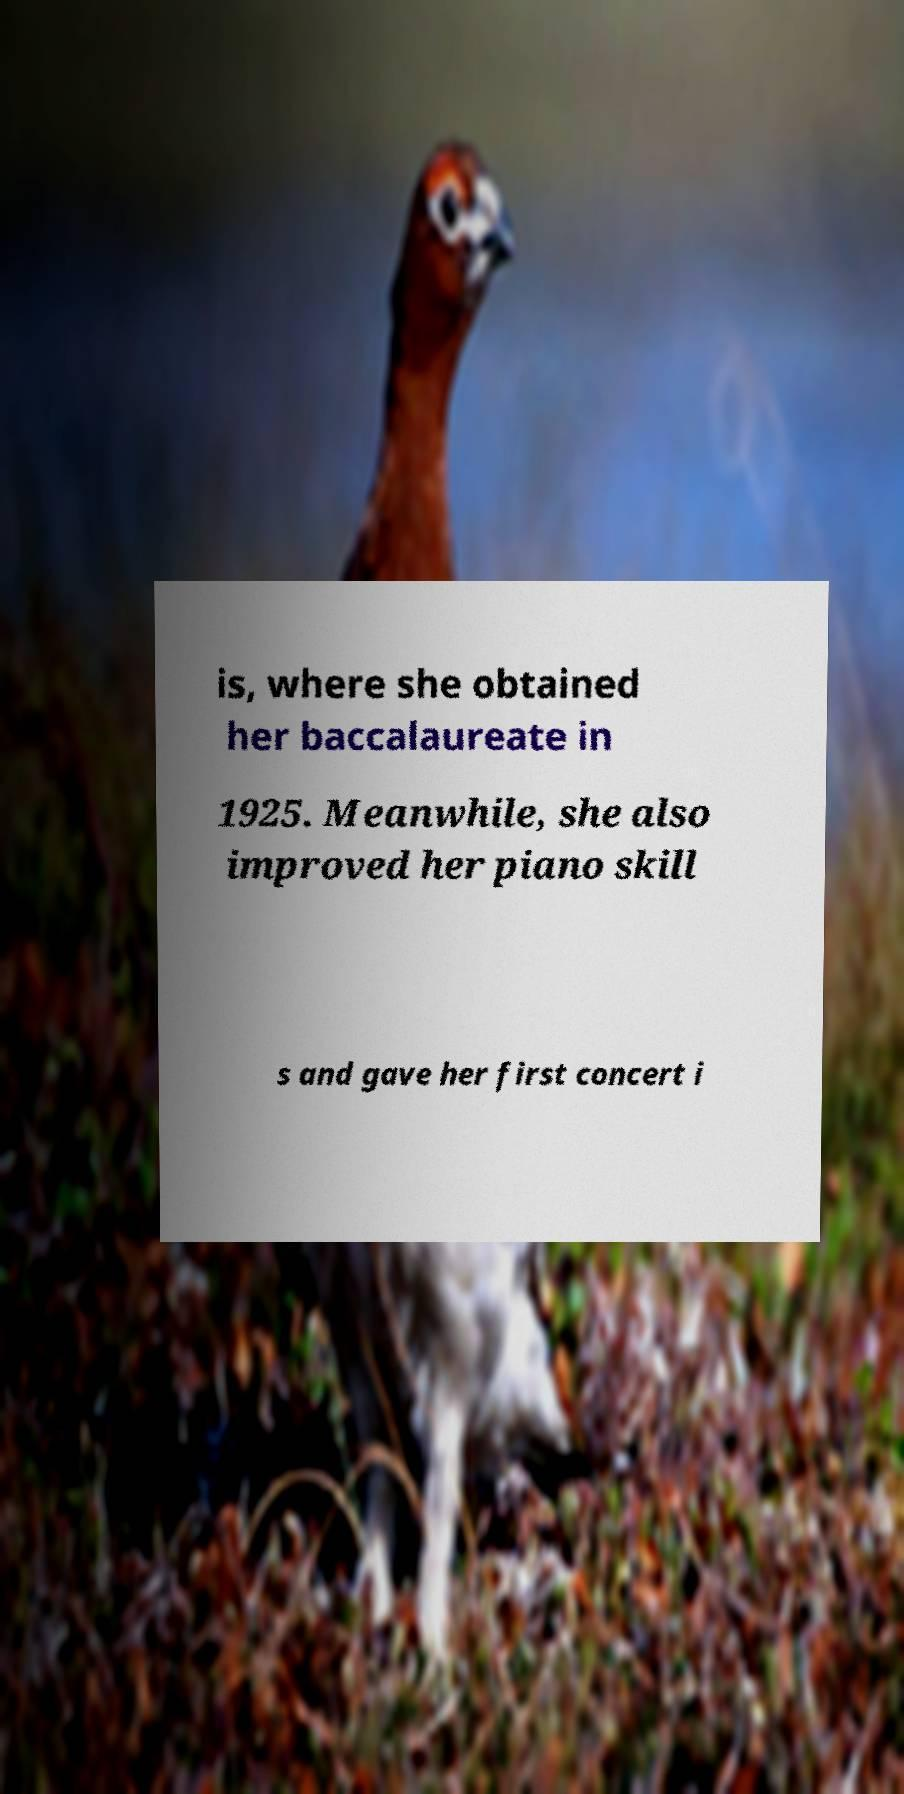For documentation purposes, I need the text within this image transcribed. Could you provide that? is, where she obtained her baccalaureate in 1925. Meanwhile, she also improved her piano skill s and gave her first concert i 